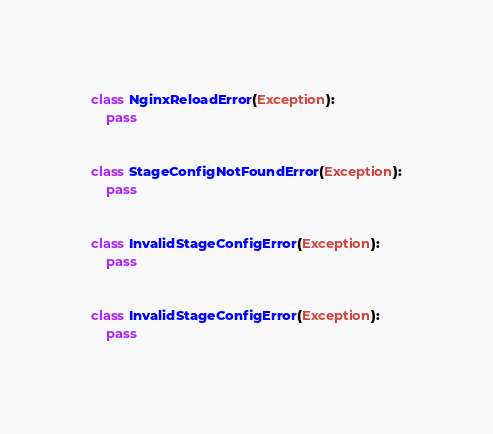<code> <loc_0><loc_0><loc_500><loc_500><_Python_>class NginxReloadError(Exception):
    pass


class StageConfigNotFoundError(Exception):
    pass


class InvalidStageConfigError(Exception):
    pass


class InvalidStageConfigError(Exception):
    pass
</code> 